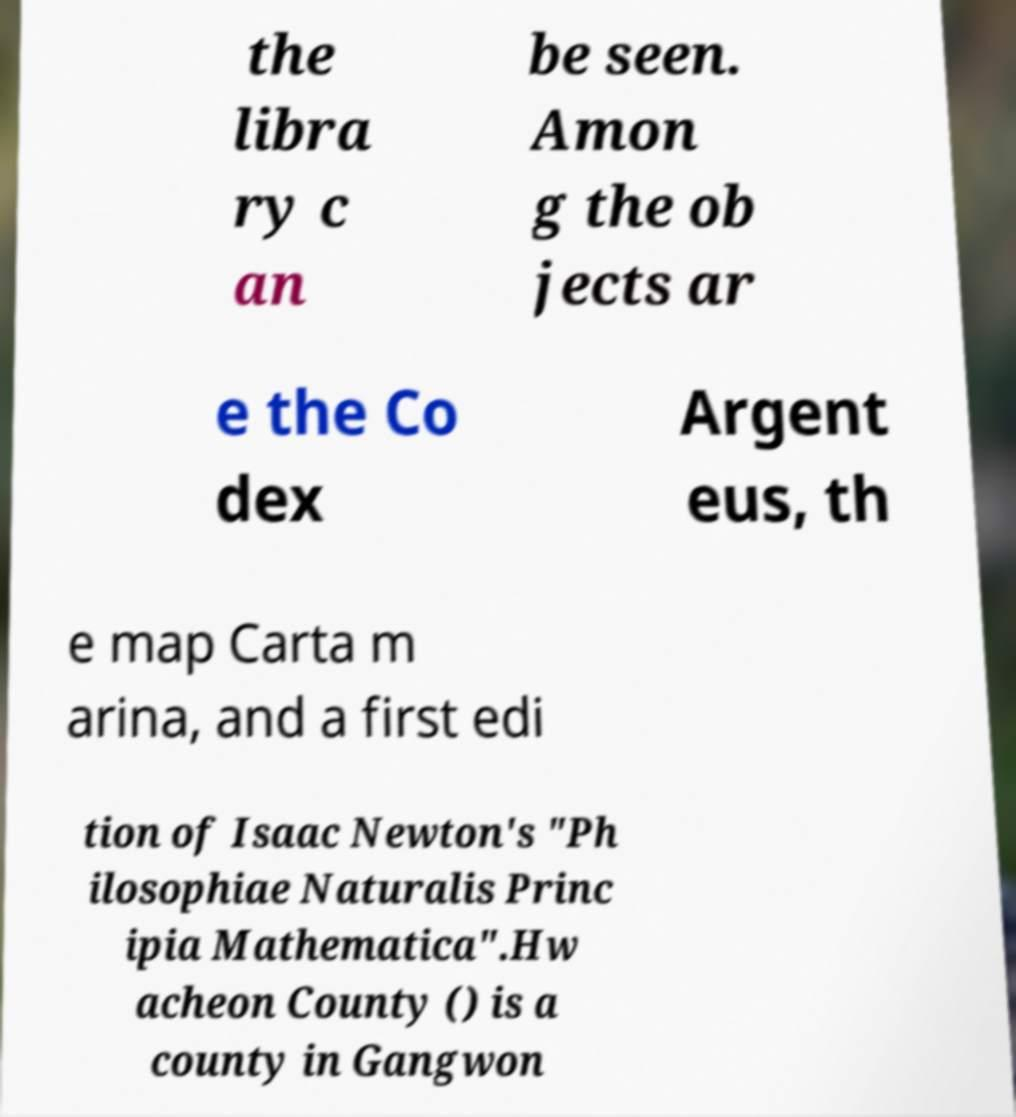Could you extract and type out the text from this image? the libra ry c an be seen. Amon g the ob jects ar e the Co dex Argent eus, th e map Carta m arina, and a first edi tion of Isaac Newton's "Ph ilosophiae Naturalis Princ ipia Mathematica".Hw acheon County () is a county in Gangwon 